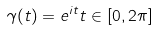<formula> <loc_0><loc_0><loc_500><loc_500>\gamma ( t ) = e ^ { i t } t \in [ 0 , 2 \pi ]</formula> 